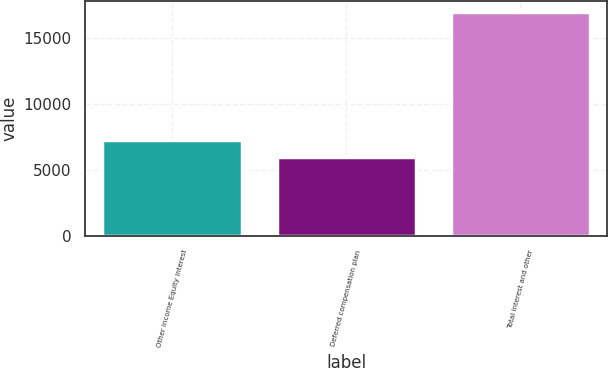Convert chart to OTSL. <chart><loc_0><loc_0><loc_500><loc_500><bar_chart><fcel>Other income Equity interest<fcel>Deferred compensation plan<fcel>Total interest and other<nl><fcel>7266<fcel>5954<fcel>16961<nl></chart> 